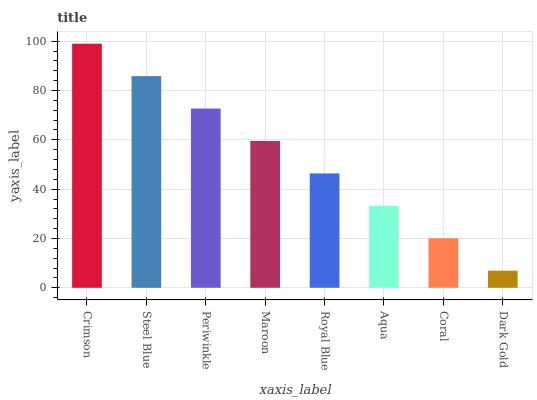Is Steel Blue the minimum?
Answer yes or no. No. Is Steel Blue the maximum?
Answer yes or no. No. Is Crimson greater than Steel Blue?
Answer yes or no. Yes. Is Steel Blue less than Crimson?
Answer yes or no. Yes. Is Steel Blue greater than Crimson?
Answer yes or no. No. Is Crimson less than Steel Blue?
Answer yes or no. No. Is Maroon the high median?
Answer yes or no. Yes. Is Royal Blue the low median?
Answer yes or no. Yes. Is Periwinkle the high median?
Answer yes or no. No. Is Dark Gold the low median?
Answer yes or no. No. 